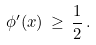Convert formula to latex. <formula><loc_0><loc_0><loc_500><loc_500>\phi ^ { \prime } ( x ) \, \geq \, \frac { 1 } { 2 } \, .</formula> 